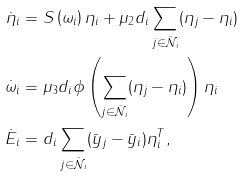Convert formula to latex. <formula><loc_0><loc_0><loc_500><loc_500>\dot { \eta } _ { i } & = S \left ( \omega _ { i } \right ) \eta _ { i } + \mu _ { 2 } d _ { i } \sum _ { j \in \mathcal { \bar { N } } _ { i } } ( \eta _ { j } - \eta _ { i } ) \\ \dot { \omega } _ { i } & = \mu _ { 3 } d _ { i } \phi \left ( \sum _ { j \in \mathcal { \bar { N } } _ { i } } ( \eta _ { j } - \eta _ { i } ) \right ) \eta _ { i } \\ \dot { E } _ { i } & = d _ { i } \sum _ { j \in \mathcal { \bar { N } } _ { i } } ( \bar { y } _ { j } - \bar { y } _ { i } ) \eta _ { i } ^ { T } ,</formula> 